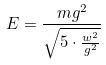Convert formula to latex. <formula><loc_0><loc_0><loc_500><loc_500>E = \frac { m g ^ { 2 } } { \sqrt { 5 \cdot \frac { w ^ { 2 } } { g ^ { 2 } } } }</formula> 